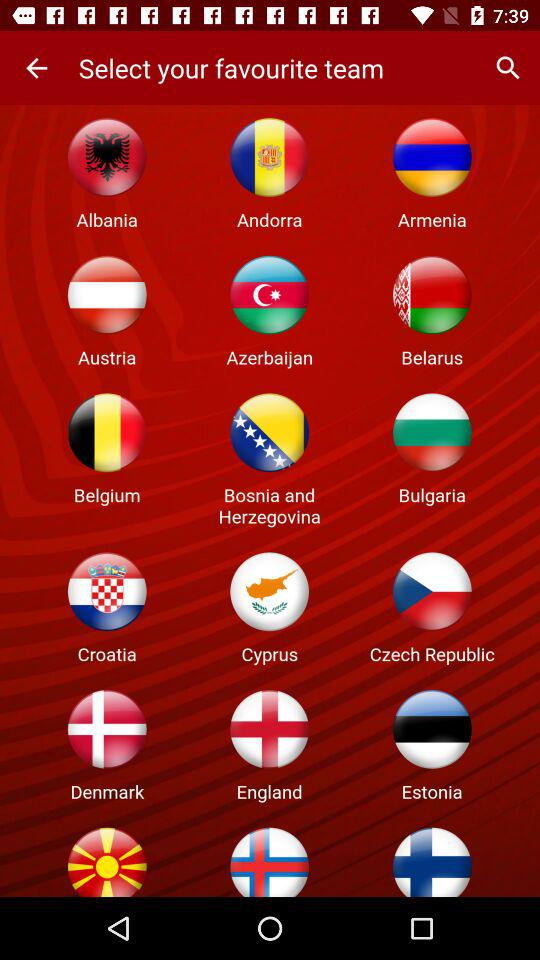How many countries have a flag that is red, white, and blue?
Answer the question using a single word or phrase. 3 